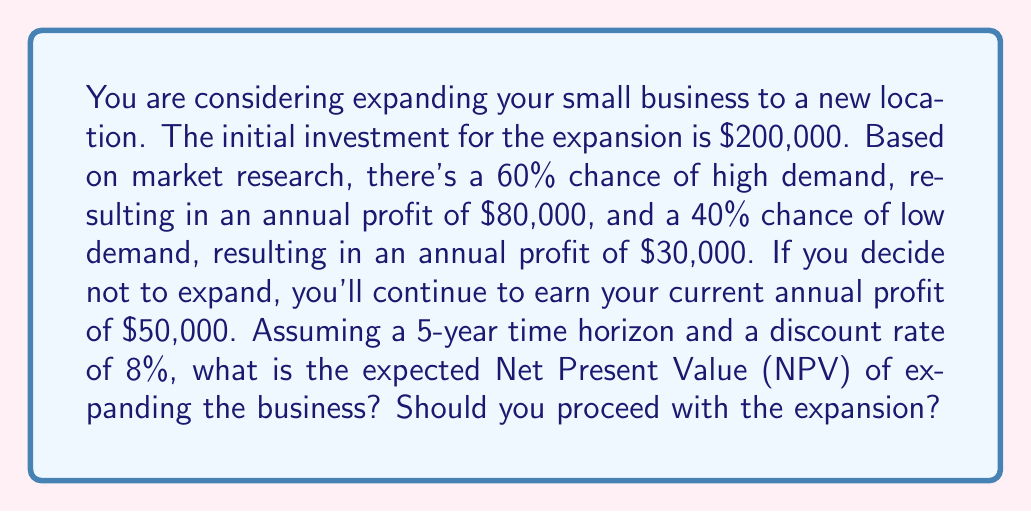Provide a solution to this math problem. To solve this problem, we need to follow these steps:

1. Calculate the expected annual profit from expansion:
   $E(\text{Profit}) = 0.60 \times \$80,000 + 0.40 \times \$30,000 = \$60,000$

2. Calculate the difference in annual profit:
   $\Delta\text{Profit} = \$60,000 - \$50,000 = \$10,000$

3. Calculate the Present Value (PV) of the profit difference over 5 years:
   Using the Present Value of an Annuity formula:
   $$PV = A \times \frac{1 - (1+r)^{-n}}{r}$$
   Where:
   $A = \$10,000$ (annual additional profit)
   $r = 0.08$ (discount rate)
   $n = 5$ (years)

   $$PV = \$10,000 \times \frac{1 - (1+0.08)^{-5}}{0.08} = \$39,927.28$$

4. Calculate the Net Present Value (NPV):
   $$NPV = -\$200,000 + \$39,927.28 = -\$160,072.72$$

The negative NPV indicates that the expansion is not financially beneficial over the 5-year period given the assumptions.
Answer: The expected Net Present Value (NPV) of expanding the business is $-\$160,072.72$. Based on this negative NPV, you should not proceed with the expansion. 